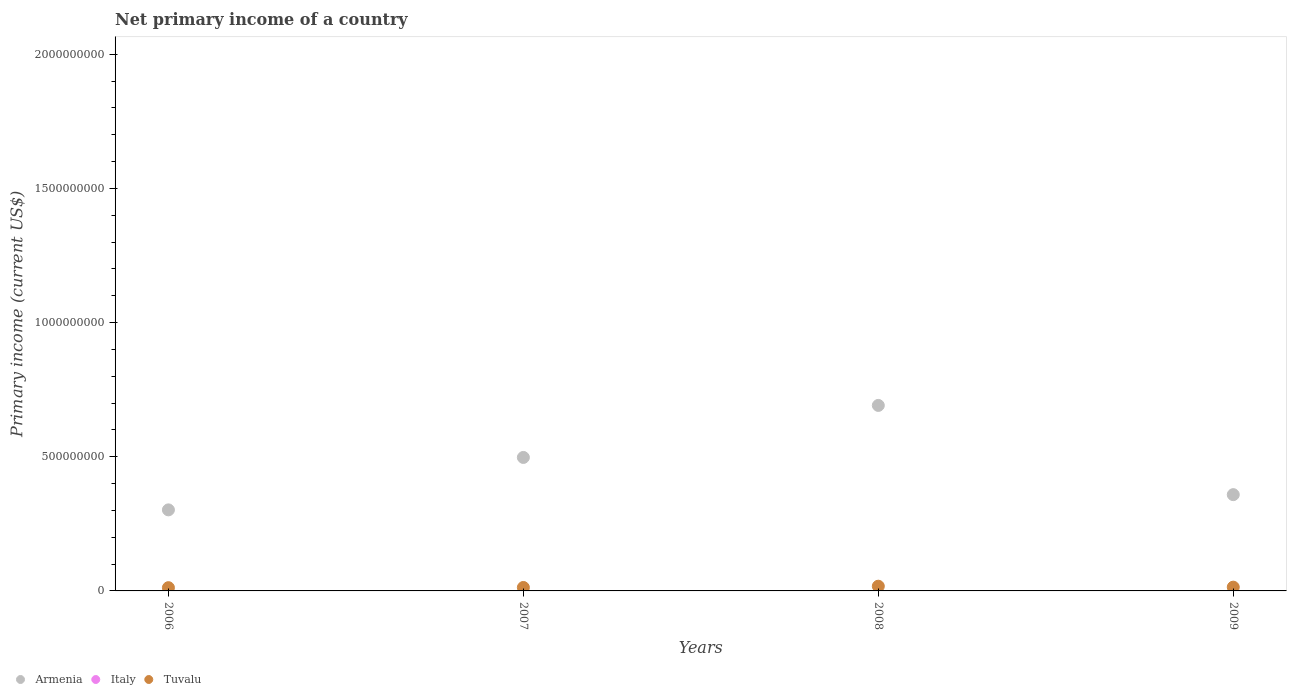What is the primary income in Tuvalu in 2007?
Offer a very short reply. 1.28e+07. Across all years, what is the maximum primary income in Tuvalu?
Give a very brief answer. 1.75e+07. Across all years, what is the minimum primary income in Tuvalu?
Give a very brief answer. 1.21e+07. In which year was the primary income in Tuvalu maximum?
Ensure brevity in your answer.  2008. What is the total primary income in Tuvalu in the graph?
Keep it short and to the point. 5.65e+07. What is the difference between the primary income in Armenia in 2006 and that in 2009?
Give a very brief answer. -5.68e+07. What is the difference between the primary income in Italy in 2009 and the primary income in Tuvalu in 2008?
Offer a terse response. -1.75e+07. What is the average primary income in Tuvalu per year?
Ensure brevity in your answer.  1.41e+07. In the year 2007, what is the difference between the primary income in Armenia and primary income in Tuvalu?
Provide a succinct answer. 4.85e+08. In how many years, is the primary income in Tuvalu greater than 800000000 US$?
Your response must be concise. 0. What is the ratio of the primary income in Tuvalu in 2006 to that in 2007?
Offer a very short reply. 0.94. What is the difference between the highest and the second highest primary income in Tuvalu?
Your response must be concise. 3.48e+06. What is the difference between the highest and the lowest primary income in Armenia?
Ensure brevity in your answer.  3.89e+08. In how many years, is the primary income in Italy greater than the average primary income in Italy taken over all years?
Offer a very short reply. 0. Is it the case that in every year, the sum of the primary income in Tuvalu and primary income in Armenia  is greater than the primary income in Italy?
Ensure brevity in your answer.  Yes. What is the difference between two consecutive major ticks on the Y-axis?
Ensure brevity in your answer.  5.00e+08. Does the graph contain any zero values?
Offer a terse response. Yes. Does the graph contain grids?
Your answer should be very brief. No. Where does the legend appear in the graph?
Ensure brevity in your answer.  Bottom left. How many legend labels are there?
Provide a short and direct response. 3. How are the legend labels stacked?
Provide a succinct answer. Horizontal. What is the title of the graph?
Your response must be concise. Net primary income of a country. Does "Lebanon" appear as one of the legend labels in the graph?
Your answer should be very brief. No. What is the label or title of the Y-axis?
Provide a succinct answer. Primary income (current US$). What is the Primary income (current US$) in Armenia in 2006?
Give a very brief answer. 3.02e+08. What is the Primary income (current US$) in Tuvalu in 2006?
Your answer should be very brief. 1.21e+07. What is the Primary income (current US$) in Armenia in 2007?
Your response must be concise. 4.97e+08. What is the Primary income (current US$) of Tuvalu in 2007?
Offer a very short reply. 1.28e+07. What is the Primary income (current US$) in Armenia in 2008?
Provide a succinct answer. 6.91e+08. What is the Primary income (current US$) of Italy in 2008?
Your response must be concise. 0. What is the Primary income (current US$) of Tuvalu in 2008?
Your response must be concise. 1.75e+07. What is the Primary income (current US$) in Armenia in 2009?
Your response must be concise. 3.59e+08. What is the Primary income (current US$) in Italy in 2009?
Provide a succinct answer. 0. What is the Primary income (current US$) in Tuvalu in 2009?
Make the answer very short. 1.41e+07. Across all years, what is the maximum Primary income (current US$) of Armenia?
Provide a succinct answer. 6.91e+08. Across all years, what is the maximum Primary income (current US$) of Tuvalu?
Provide a succinct answer. 1.75e+07. Across all years, what is the minimum Primary income (current US$) in Armenia?
Give a very brief answer. 3.02e+08. Across all years, what is the minimum Primary income (current US$) of Tuvalu?
Your response must be concise. 1.21e+07. What is the total Primary income (current US$) of Armenia in the graph?
Offer a very short reply. 1.85e+09. What is the total Primary income (current US$) of Italy in the graph?
Your answer should be very brief. 0. What is the total Primary income (current US$) of Tuvalu in the graph?
Keep it short and to the point. 5.65e+07. What is the difference between the Primary income (current US$) in Armenia in 2006 and that in 2007?
Your response must be concise. -1.95e+08. What is the difference between the Primary income (current US$) of Tuvalu in 2006 and that in 2007?
Give a very brief answer. -7.59e+05. What is the difference between the Primary income (current US$) in Armenia in 2006 and that in 2008?
Provide a succinct answer. -3.89e+08. What is the difference between the Primary income (current US$) in Tuvalu in 2006 and that in 2008?
Your response must be concise. -5.46e+06. What is the difference between the Primary income (current US$) in Armenia in 2006 and that in 2009?
Your response must be concise. -5.68e+07. What is the difference between the Primary income (current US$) of Tuvalu in 2006 and that in 2009?
Provide a short and direct response. -1.98e+06. What is the difference between the Primary income (current US$) of Armenia in 2007 and that in 2008?
Ensure brevity in your answer.  -1.94e+08. What is the difference between the Primary income (current US$) of Tuvalu in 2007 and that in 2008?
Provide a succinct answer. -4.70e+06. What is the difference between the Primary income (current US$) in Armenia in 2007 and that in 2009?
Your answer should be very brief. 1.39e+08. What is the difference between the Primary income (current US$) of Tuvalu in 2007 and that in 2009?
Give a very brief answer. -1.22e+06. What is the difference between the Primary income (current US$) of Armenia in 2008 and that in 2009?
Provide a succinct answer. 3.32e+08. What is the difference between the Primary income (current US$) in Tuvalu in 2008 and that in 2009?
Provide a succinct answer. 3.48e+06. What is the difference between the Primary income (current US$) of Armenia in 2006 and the Primary income (current US$) of Tuvalu in 2007?
Give a very brief answer. 2.89e+08. What is the difference between the Primary income (current US$) in Armenia in 2006 and the Primary income (current US$) in Tuvalu in 2008?
Provide a short and direct response. 2.84e+08. What is the difference between the Primary income (current US$) in Armenia in 2006 and the Primary income (current US$) in Tuvalu in 2009?
Provide a short and direct response. 2.88e+08. What is the difference between the Primary income (current US$) in Armenia in 2007 and the Primary income (current US$) in Tuvalu in 2008?
Ensure brevity in your answer.  4.80e+08. What is the difference between the Primary income (current US$) in Armenia in 2007 and the Primary income (current US$) in Tuvalu in 2009?
Your answer should be very brief. 4.83e+08. What is the difference between the Primary income (current US$) of Armenia in 2008 and the Primary income (current US$) of Tuvalu in 2009?
Your response must be concise. 6.77e+08. What is the average Primary income (current US$) in Armenia per year?
Keep it short and to the point. 4.62e+08. What is the average Primary income (current US$) in Tuvalu per year?
Your answer should be compact. 1.41e+07. In the year 2006, what is the difference between the Primary income (current US$) in Armenia and Primary income (current US$) in Tuvalu?
Your answer should be very brief. 2.90e+08. In the year 2007, what is the difference between the Primary income (current US$) of Armenia and Primary income (current US$) of Tuvalu?
Your response must be concise. 4.85e+08. In the year 2008, what is the difference between the Primary income (current US$) in Armenia and Primary income (current US$) in Tuvalu?
Your answer should be very brief. 6.74e+08. In the year 2009, what is the difference between the Primary income (current US$) in Armenia and Primary income (current US$) in Tuvalu?
Give a very brief answer. 3.45e+08. What is the ratio of the Primary income (current US$) in Armenia in 2006 to that in 2007?
Your answer should be compact. 0.61. What is the ratio of the Primary income (current US$) of Tuvalu in 2006 to that in 2007?
Your answer should be compact. 0.94. What is the ratio of the Primary income (current US$) in Armenia in 2006 to that in 2008?
Provide a succinct answer. 0.44. What is the ratio of the Primary income (current US$) in Tuvalu in 2006 to that in 2008?
Keep it short and to the point. 0.69. What is the ratio of the Primary income (current US$) in Armenia in 2006 to that in 2009?
Offer a very short reply. 0.84. What is the ratio of the Primary income (current US$) in Tuvalu in 2006 to that in 2009?
Your answer should be very brief. 0.86. What is the ratio of the Primary income (current US$) in Armenia in 2007 to that in 2008?
Offer a terse response. 0.72. What is the ratio of the Primary income (current US$) in Tuvalu in 2007 to that in 2008?
Your answer should be compact. 0.73. What is the ratio of the Primary income (current US$) in Armenia in 2007 to that in 2009?
Keep it short and to the point. 1.39. What is the ratio of the Primary income (current US$) in Tuvalu in 2007 to that in 2009?
Offer a terse response. 0.91. What is the ratio of the Primary income (current US$) in Armenia in 2008 to that in 2009?
Make the answer very short. 1.93. What is the ratio of the Primary income (current US$) in Tuvalu in 2008 to that in 2009?
Offer a terse response. 1.25. What is the difference between the highest and the second highest Primary income (current US$) of Armenia?
Provide a short and direct response. 1.94e+08. What is the difference between the highest and the second highest Primary income (current US$) of Tuvalu?
Keep it short and to the point. 3.48e+06. What is the difference between the highest and the lowest Primary income (current US$) in Armenia?
Make the answer very short. 3.89e+08. What is the difference between the highest and the lowest Primary income (current US$) of Tuvalu?
Your answer should be compact. 5.46e+06. 